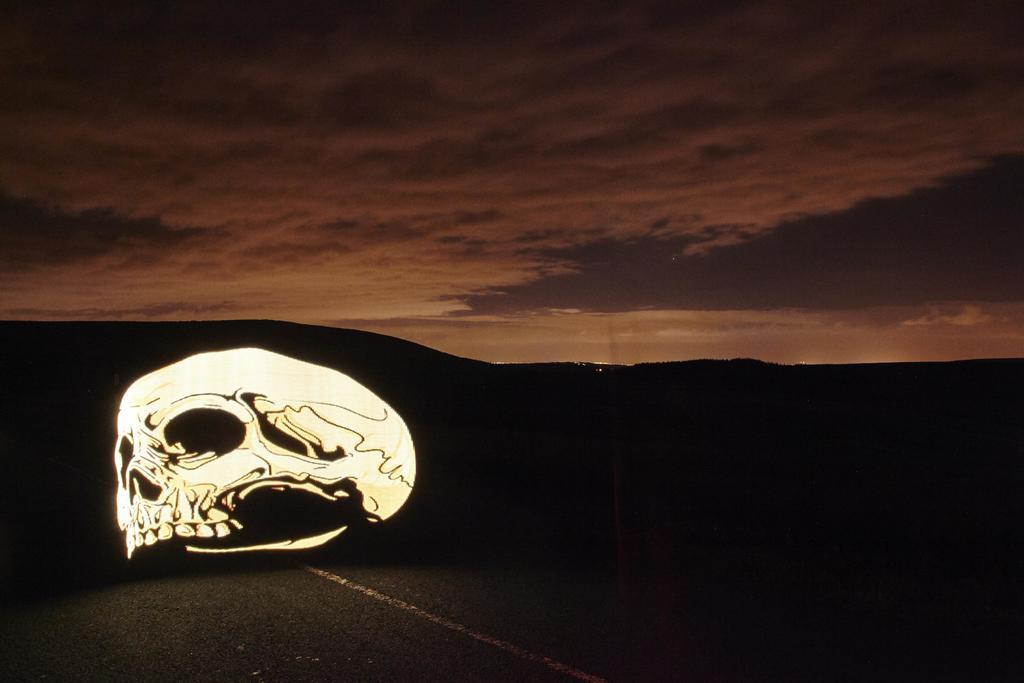What object is located on the road in the image? There is a skull on the road in the image. What type of landscape can be seen in the background of the image? Hills are visible in the background of the image. What is visible at the top of the image? The sky is visible at the top of the image. What type of feast is being held in the image? There is no feast present in the image; it features a skull on the road and hills in the background. Where is the meeting taking place in the image? There is no meeting present in the image; it features a skull on the road and hills in the background. 